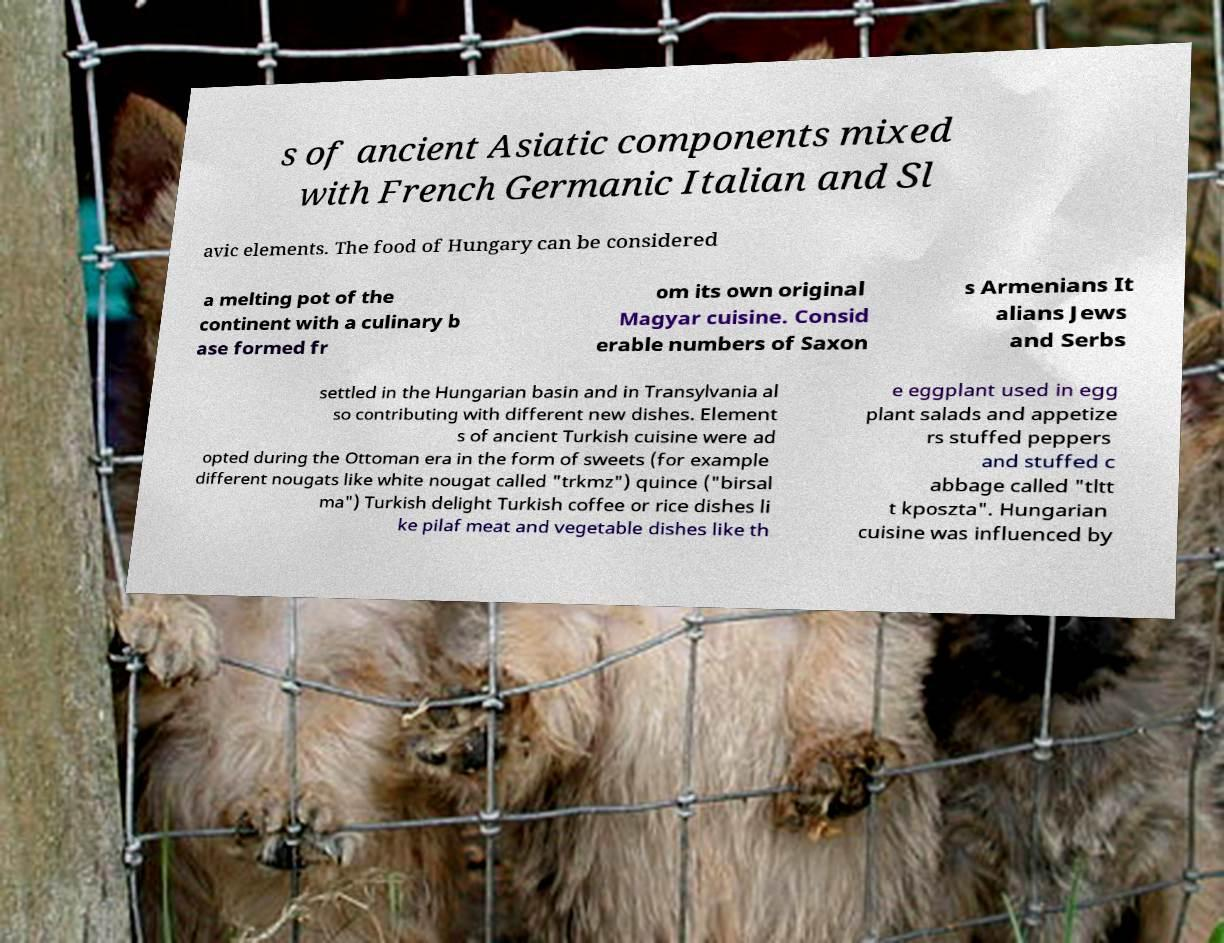Could you assist in decoding the text presented in this image and type it out clearly? s of ancient Asiatic components mixed with French Germanic Italian and Sl avic elements. The food of Hungary can be considered a melting pot of the continent with a culinary b ase formed fr om its own original Magyar cuisine. Consid erable numbers of Saxon s Armenians It alians Jews and Serbs settled in the Hungarian basin and in Transylvania al so contributing with different new dishes. Element s of ancient Turkish cuisine were ad opted during the Ottoman era in the form of sweets (for example different nougats like white nougat called "trkmz") quince ("birsal ma") Turkish delight Turkish coffee or rice dishes li ke pilaf meat and vegetable dishes like th e eggplant used in egg plant salads and appetize rs stuffed peppers and stuffed c abbage called "tltt t kposzta". Hungarian cuisine was influenced by 